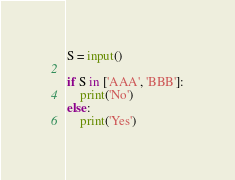<code> <loc_0><loc_0><loc_500><loc_500><_Python_>S = input()

if S in ['AAA', 'BBB']:
    print('No')
else:
    print('Yes')</code> 